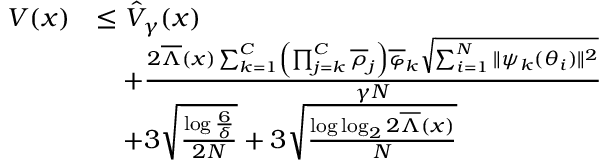<formula> <loc_0><loc_0><loc_500><loc_500>\begin{array} { r l } { V ( x ) } & { \leq \hat { V } _ { \gamma } ( x ) } \\ & { \quad + \frac { 2 \overline { \Lambda } ( x ) \sum _ { k = 1 } ^ { C } \left ( \prod _ { j = k } ^ { C } \overline { \rho } _ { j } \right ) \overline { \varphi } _ { k } \sqrt { \sum _ { i = 1 } ^ { N } \| \psi _ { k } ( \theta _ { i } ) \| ^ { 2 } } } { \gamma N } } \\ & { \quad + 3 \sqrt { \frac { \log \frac { 6 } { \delta } } { 2 N } } + 3 \sqrt { \frac { \log \log _ { 2 } 2 \overline { \Lambda } ( x ) } { N } } } \end{array}</formula> 